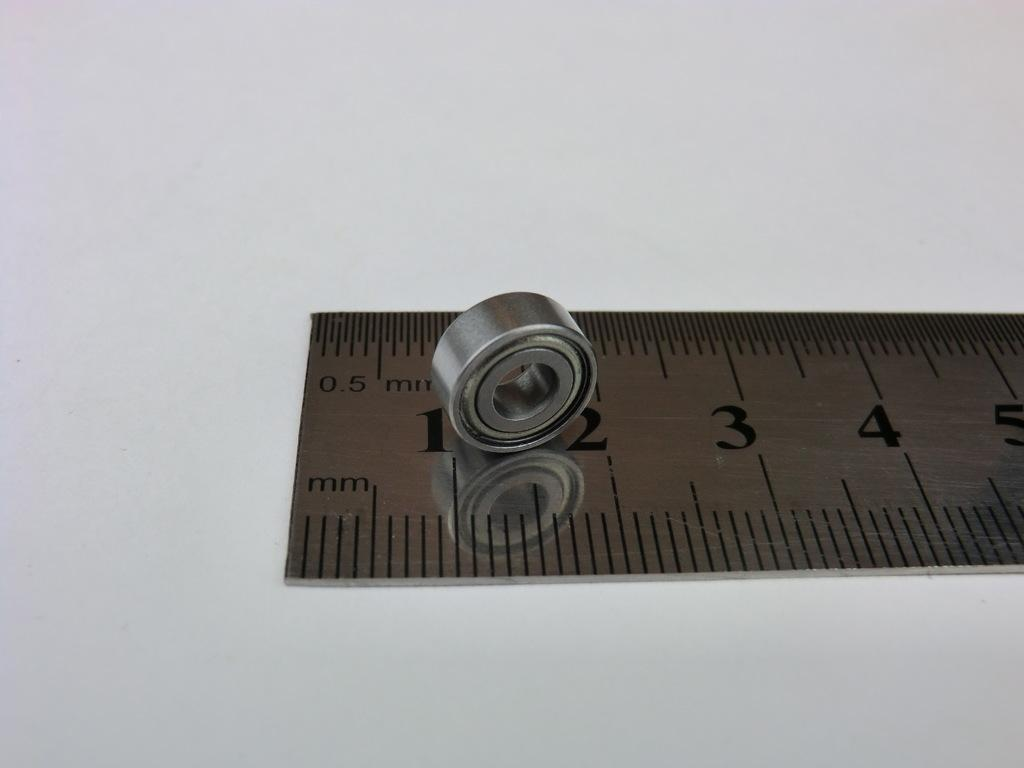What object in the image is used for fastening or securing? There is a bolt in the image that is used for fastening or securing. What object in the image is used for measuring weight or mass? There is a scale in the image that is used for measuring weight or mass. What surface is present in the image that can support objects or people? There is a platform in the image that can support objects or people. How many snakes are wrapped around the bolt in the image? There are no snakes present in the image; it only features a bolt, a scale, and a platform. What type of lace is draped over the scale in the image? There is no lace present in the image; it only features a bolt, a scale, and a platform. 